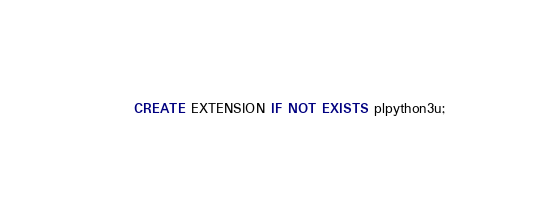Convert code to text. <code><loc_0><loc_0><loc_500><loc_500><_SQL_>CREATE EXTENSION IF NOT EXISTS plpython3u;
</code> 